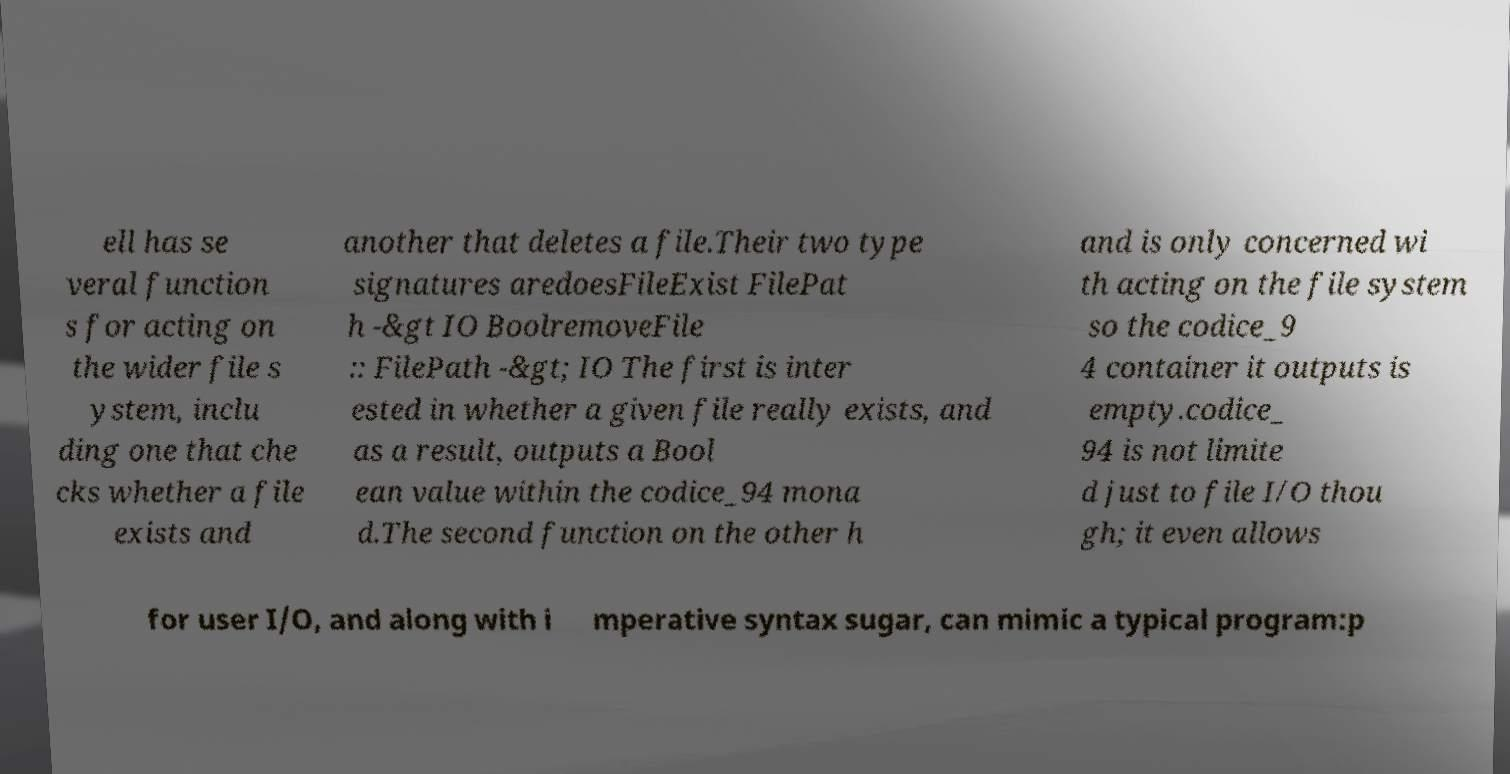I need the written content from this picture converted into text. Can you do that? ell has se veral function s for acting on the wider file s ystem, inclu ding one that che cks whether a file exists and another that deletes a file.Their two type signatures aredoesFileExist FilePat h -&gt IO BoolremoveFile :: FilePath -&gt; IO The first is inter ested in whether a given file really exists, and as a result, outputs a Bool ean value within the codice_94 mona d.The second function on the other h and is only concerned wi th acting on the file system so the codice_9 4 container it outputs is empty.codice_ 94 is not limite d just to file I/O thou gh; it even allows for user I/O, and along with i mperative syntax sugar, can mimic a typical program:p 